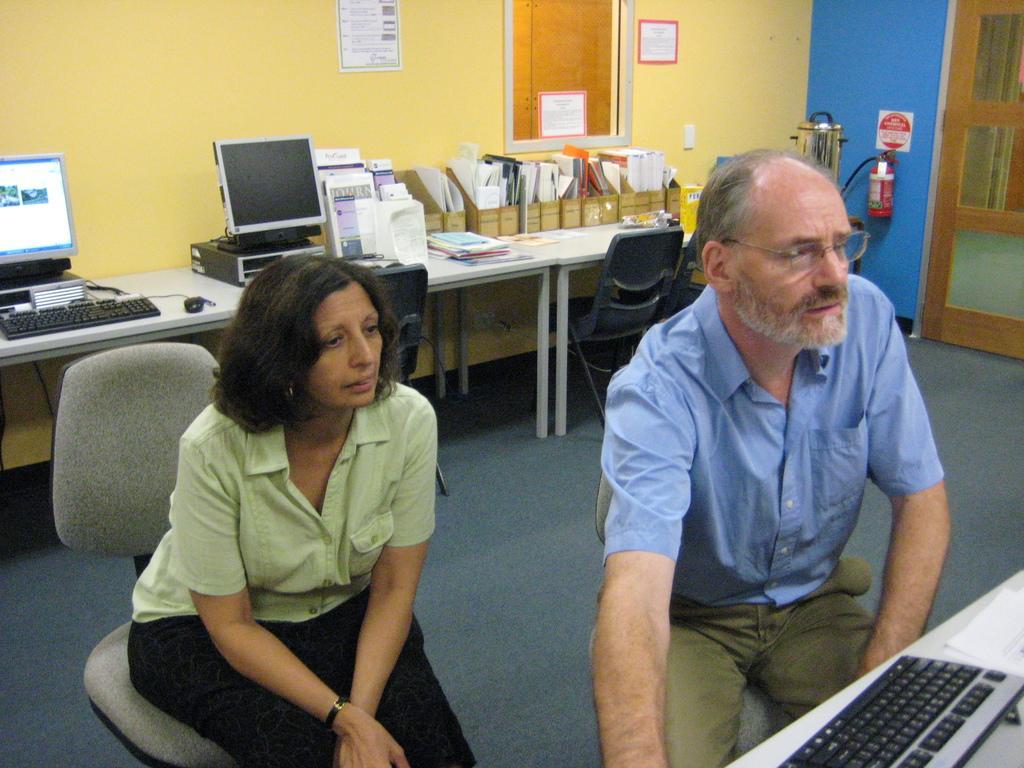In one or two sentences, can you explain what this image depicts? In the foreground of the image we can see a keyboard and two persons are sitting on the chairs. In the middle of the image we can see a table on which two computers and some objects are there. On the top of the image we can see a window and two posters. 